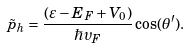<formula> <loc_0><loc_0><loc_500><loc_500>\tilde { p } _ { h } = \frac { ( \varepsilon - E _ { F } + V _ { 0 } ) } { \hbar { \upsilon } _ { F } } \cos ( \theta ^ { \prime } ) .</formula> 